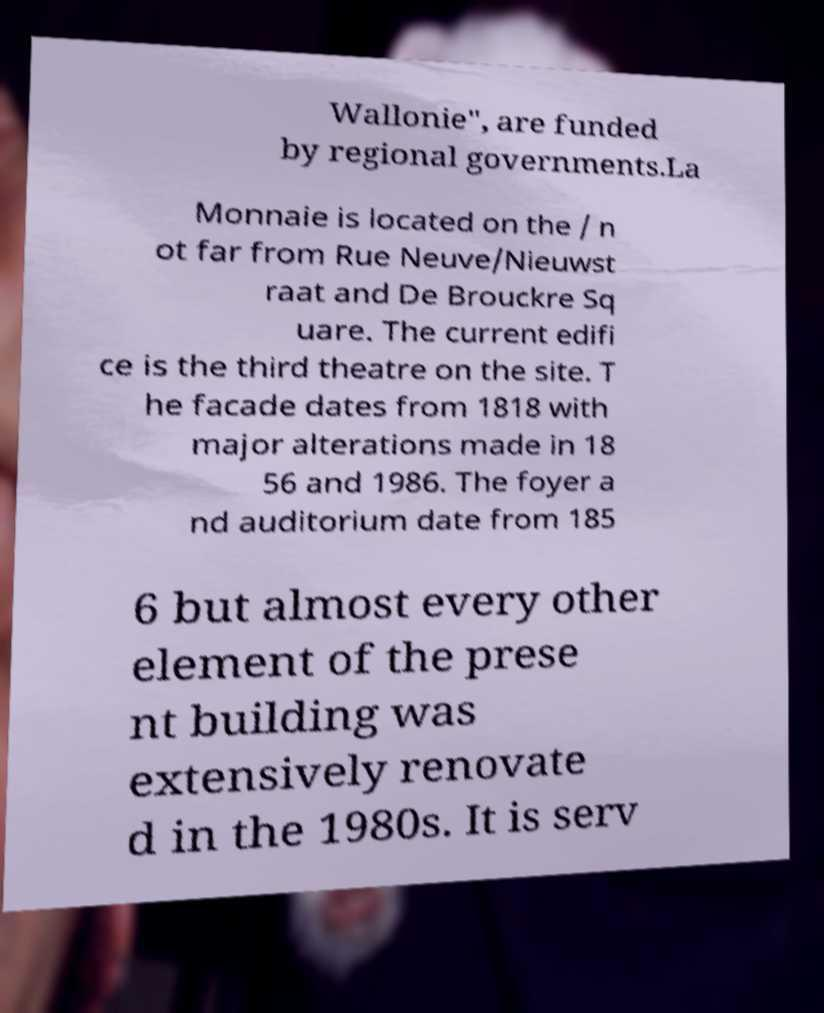What messages or text are displayed in this image? I need them in a readable, typed format. Wallonie", are funded by regional governments.La Monnaie is located on the / n ot far from Rue Neuve/Nieuwst raat and De Brouckre Sq uare. The current edifi ce is the third theatre on the site. T he facade dates from 1818 with major alterations made in 18 56 and 1986. The foyer a nd auditorium date from 185 6 but almost every other element of the prese nt building was extensively renovate d in the 1980s. It is serv 